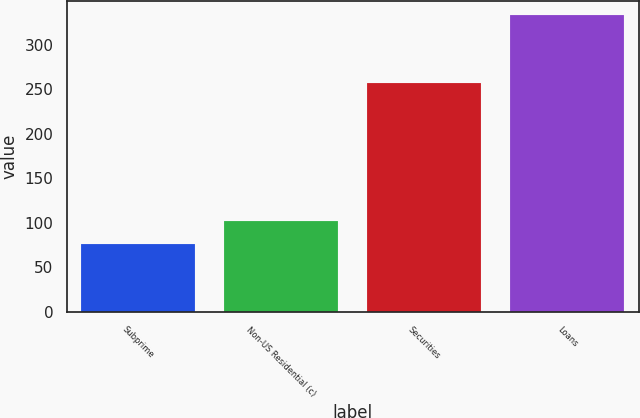Convert chart to OTSL. <chart><loc_0><loc_0><loc_500><loc_500><bar_chart><fcel>Subprime<fcel>Non-US Residential (c)<fcel>Securities<fcel>Loans<nl><fcel>76<fcel>101.7<fcel>257<fcel>333<nl></chart> 